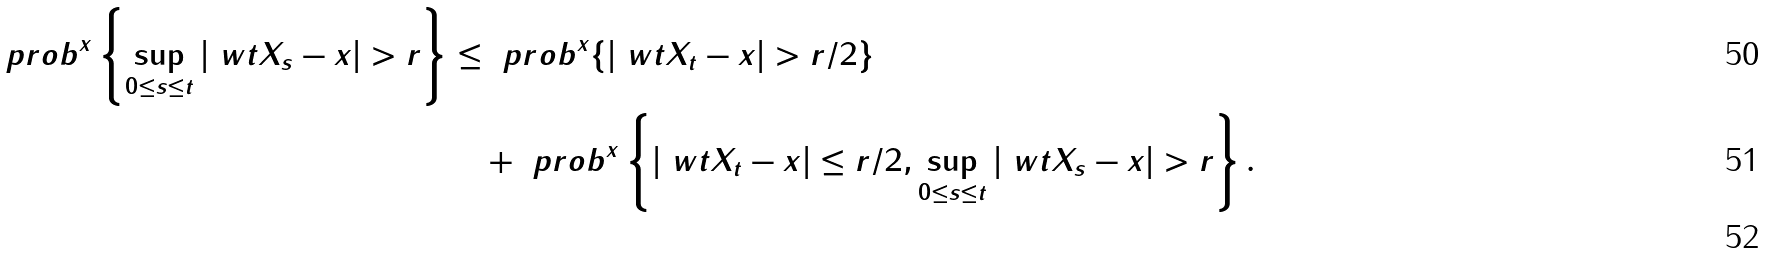Convert formula to latex. <formula><loc_0><loc_0><loc_500><loc_500>\ p r o b ^ { x } \left \{ \sup _ { 0 \leq s \leq t } | \ w t X _ { s } - x | > r \right \} & \leq \ p r o b ^ { x } \{ | \ w t X _ { t } - x | > r / 2 \} \\ & \quad + \ p r o b ^ { x } \left \{ | \ w t X _ { t } - x | \leq r / 2 , \sup _ { 0 \leq s \leq t } | \ w t X _ { s } - x | > r \right \} . \\</formula> 